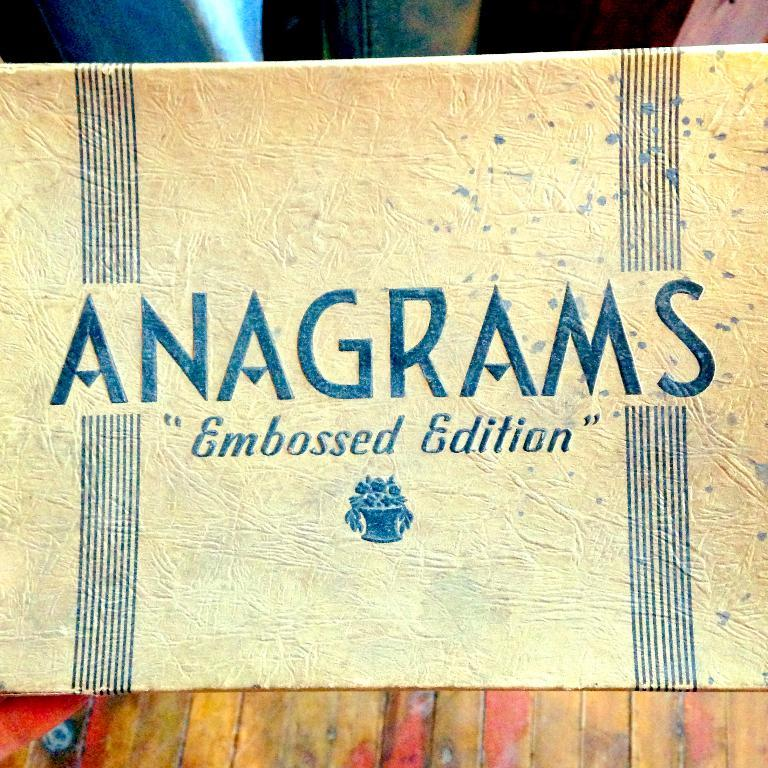<image>
Render a clear and concise summary of the photo. The embossed edition of Anagrams has blue stripes on the cover. 